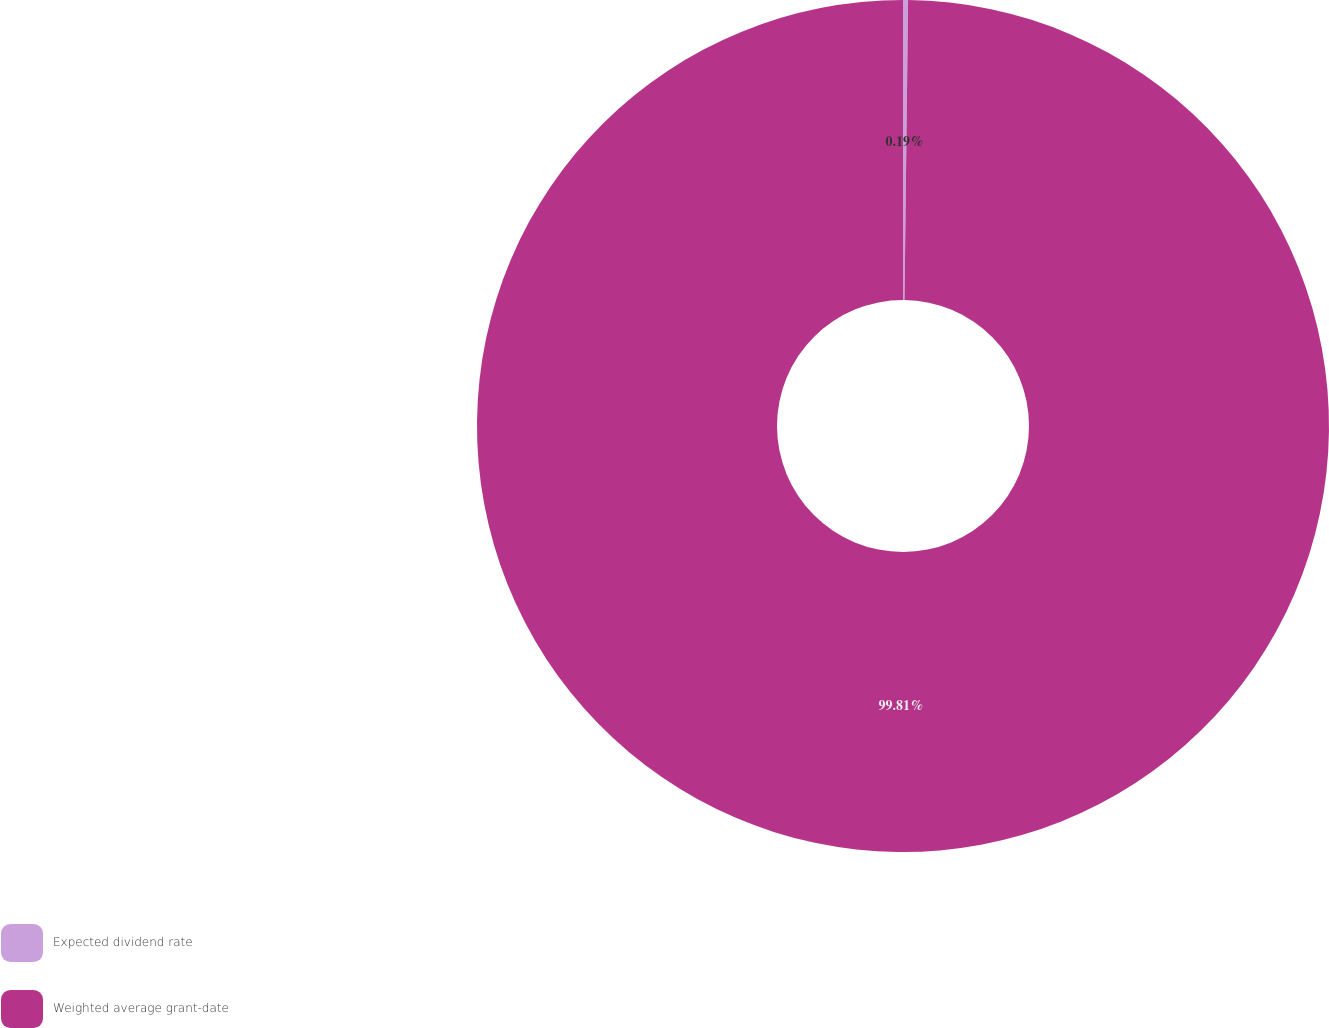<chart> <loc_0><loc_0><loc_500><loc_500><pie_chart><fcel>Expected dividend rate<fcel>Weighted average grant-date<nl><fcel>0.19%<fcel>99.81%<nl></chart> 